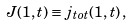<formula> <loc_0><loc_0><loc_500><loc_500>J ( 1 , t ) \equiv j _ { t o t } ( 1 , t ) \, ,</formula> 